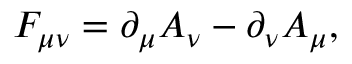<formula> <loc_0><loc_0><loc_500><loc_500>F _ { \mu \nu } = \partial _ { \mu } A _ { \nu } - \partial _ { \nu } A _ { \mu } ,</formula> 